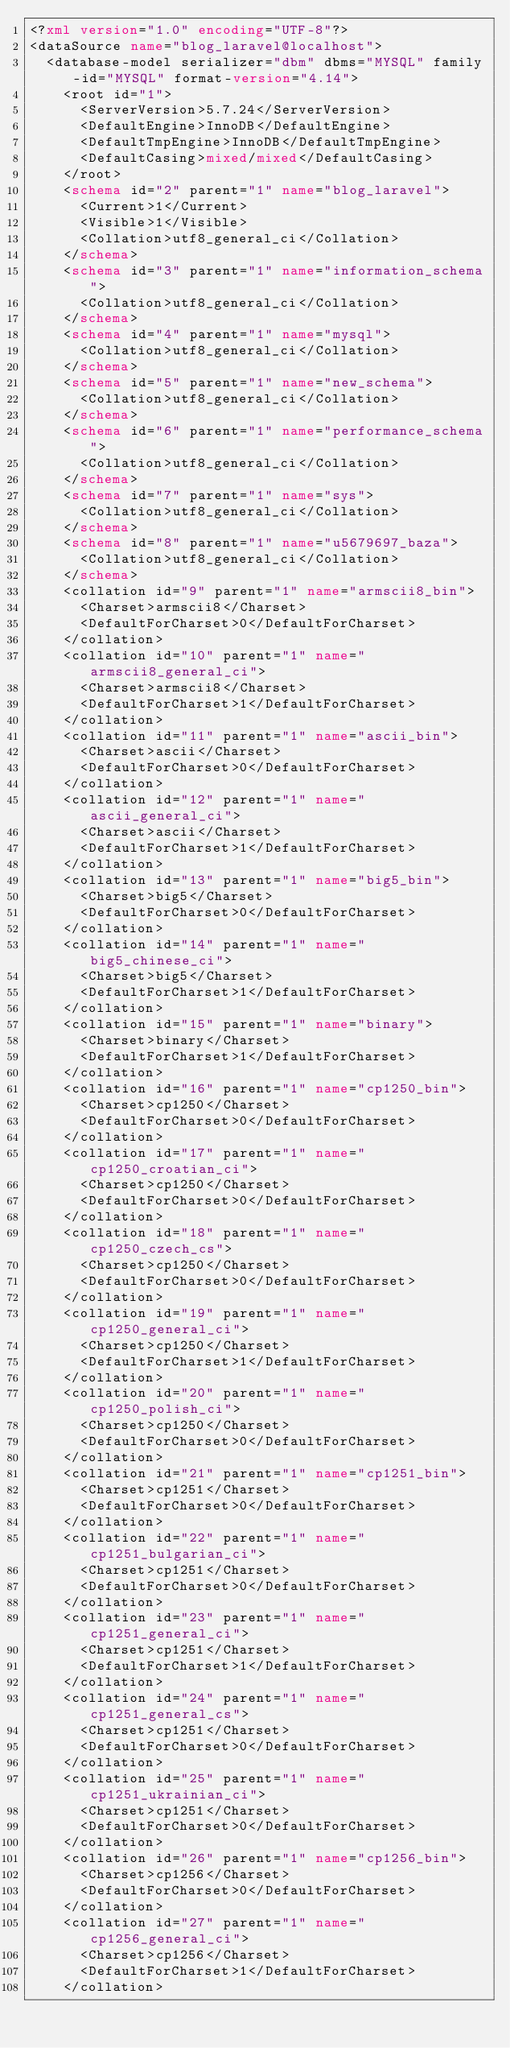Convert code to text. <code><loc_0><loc_0><loc_500><loc_500><_XML_><?xml version="1.0" encoding="UTF-8"?>
<dataSource name="blog_laravel@localhost">
  <database-model serializer="dbm" dbms="MYSQL" family-id="MYSQL" format-version="4.14">
    <root id="1">
      <ServerVersion>5.7.24</ServerVersion>
      <DefaultEngine>InnoDB</DefaultEngine>
      <DefaultTmpEngine>InnoDB</DefaultTmpEngine>
      <DefaultCasing>mixed/mixed</DefaultCasing>
    </root>
    <schema id="2" parent="1" name="blog_laravel">
      <Current>1</Current>
      <Visible>1</Visible>
      <Collation>utf8_general_ci</Collation>
    </schema>
    <schema id="3" parent="1" name="information_schema">
      <Collation>utf8_general_ci</Collation>
    </schema>
    <schema id="4" parent="1" name="mysql">
      <Collation>utf8_general_ci</Collation>
    </schema>
    <schema id="5" parent="1" name="new_schema">
      <Collation>utf8_general_ci</Collation>
    </schema>
    <schema id="6" parent="1" name="performance_schema">
      <Collation>utf8_general_ci</Collation>
    </schema>
    <schema id="7" parent="1" name="sys">
      <Collation>utf8_general_ci</Collation>
    </schema>
    <schema id="8" parent="1" name="u5679697_baza">
      <Collation>utf8_general_ci</Collation>
    </schema>
    <collation id="9" parent="1" name="armscii8_bin">
      <Charset>armscii8</Charset>
      <DefaultForCharset>0</DefaultForCharset>
    </collation>
    <collation id="10" parent="1" name="armscii8_general_ci">
      <Charset>armscii8</Charset>
      <DefaultForCharset>1</DefaultForCharset>
    </collation>
    <collation id="11" parent="1" name="ascii_bin">
      <Charset>ascii</Charset>
      <DefaultForCharset>0</DefaultForCharset>
    </collation>
    <collation id="12" parent="1" name="ascii_general_ci">
      <Charset>ascii</Charset>
      <DefaultForCharset>1</DefaultForCharset>
    </collation>
    <collation id="13" parent="1" name="big5_bin">
      <Charset>big5</Charset>
      <DefaultForCharset>0</DefaultForCharset>
    </collation>
    <collation id="14" parent="1" name="big5_chinese_ci">
      <Charset>big5</Charset>
      <DefaultForCharset>1</DefaultForCharset>
    </collation>
    <collation id="15" parent="1" name="binary">
      <Charset>binary</Charset>
      <DefaultForCharset>1</DefaultForCharset>
    </collation>
    <collation id="16" parent="1" name="cp1250_bin">
      <Charset>cp1250</Charset>
      <DefaultForCharset>0</DefaultForCharset>
    </collation>
    <collation id="17" parent="1" name="cp1250_croatian_ci">
      <Charset>cp1250</Charset>
      <DefaultForCharset>0</DefaultForCharset>
    </collation>
    <collation id="18" parent="1" name="cp1250_czech_cs">
      <Charset>cp1250</Charset>
      <DefaultForCharset>0</DefaultForCharset>
    </collation>
    <collation id="19" parent="1" name="cp1250_general_ci">
      <Charset>cp1250</Charset>
      <DefaultForCharset>1</DefaultForCharset>
    </collation>
    <collation id="20" parent="1" name="cp1250_polish_ci">
      <Charset>cp1250</Charset>
      <DefaultForCharset>0</DefaultForCharset>
    </collation>
    <collation id="21" parent="1" name="cp1251_bin">
      <Charset>cp1251</Charset>
      <DefaultForCharset>0</DefaultForCharset>
    </collation>
    <collation id="22" parent="1" name="cp1251_bulgarian_ci">
      <Charset>cp1251</Charset>
      <DefaultForCharset>0</DefaultForCharset>
    </collation>
    <collation id="23" parent="1" name="cp1251_general_ci">
      <Charset>cp1251</Charset>
      <DefaultForCharset>1</DefaultForCharset>
    </collation>
    <collation id="24" parent="1" name="cp1251_general_cs">
      <Charset>cp1251</Charset>
      <DefaultForCharset>0</DefaultForCharset>
    </collation>
    <collation id="25" parent="1" name="cp1251_ukrainian_ci">
      <Charset>cp1251</Charset>
      <DefaultForCharset>0</DefaultForCharset>
    </collation>
    <collation id="26" parent="1" name="cp1256_bin">
      <Charset>cp1256</Charset>
      <DefaultForCharset>0</DefaultForCharset>
    </collation>
    <collation id="27" parent="1" name="cp1256_general_ci">
      <Charset>cp1256</Charset>
      <DefaultForCharset>1</DefaultForCharset>
    </collation></code> 